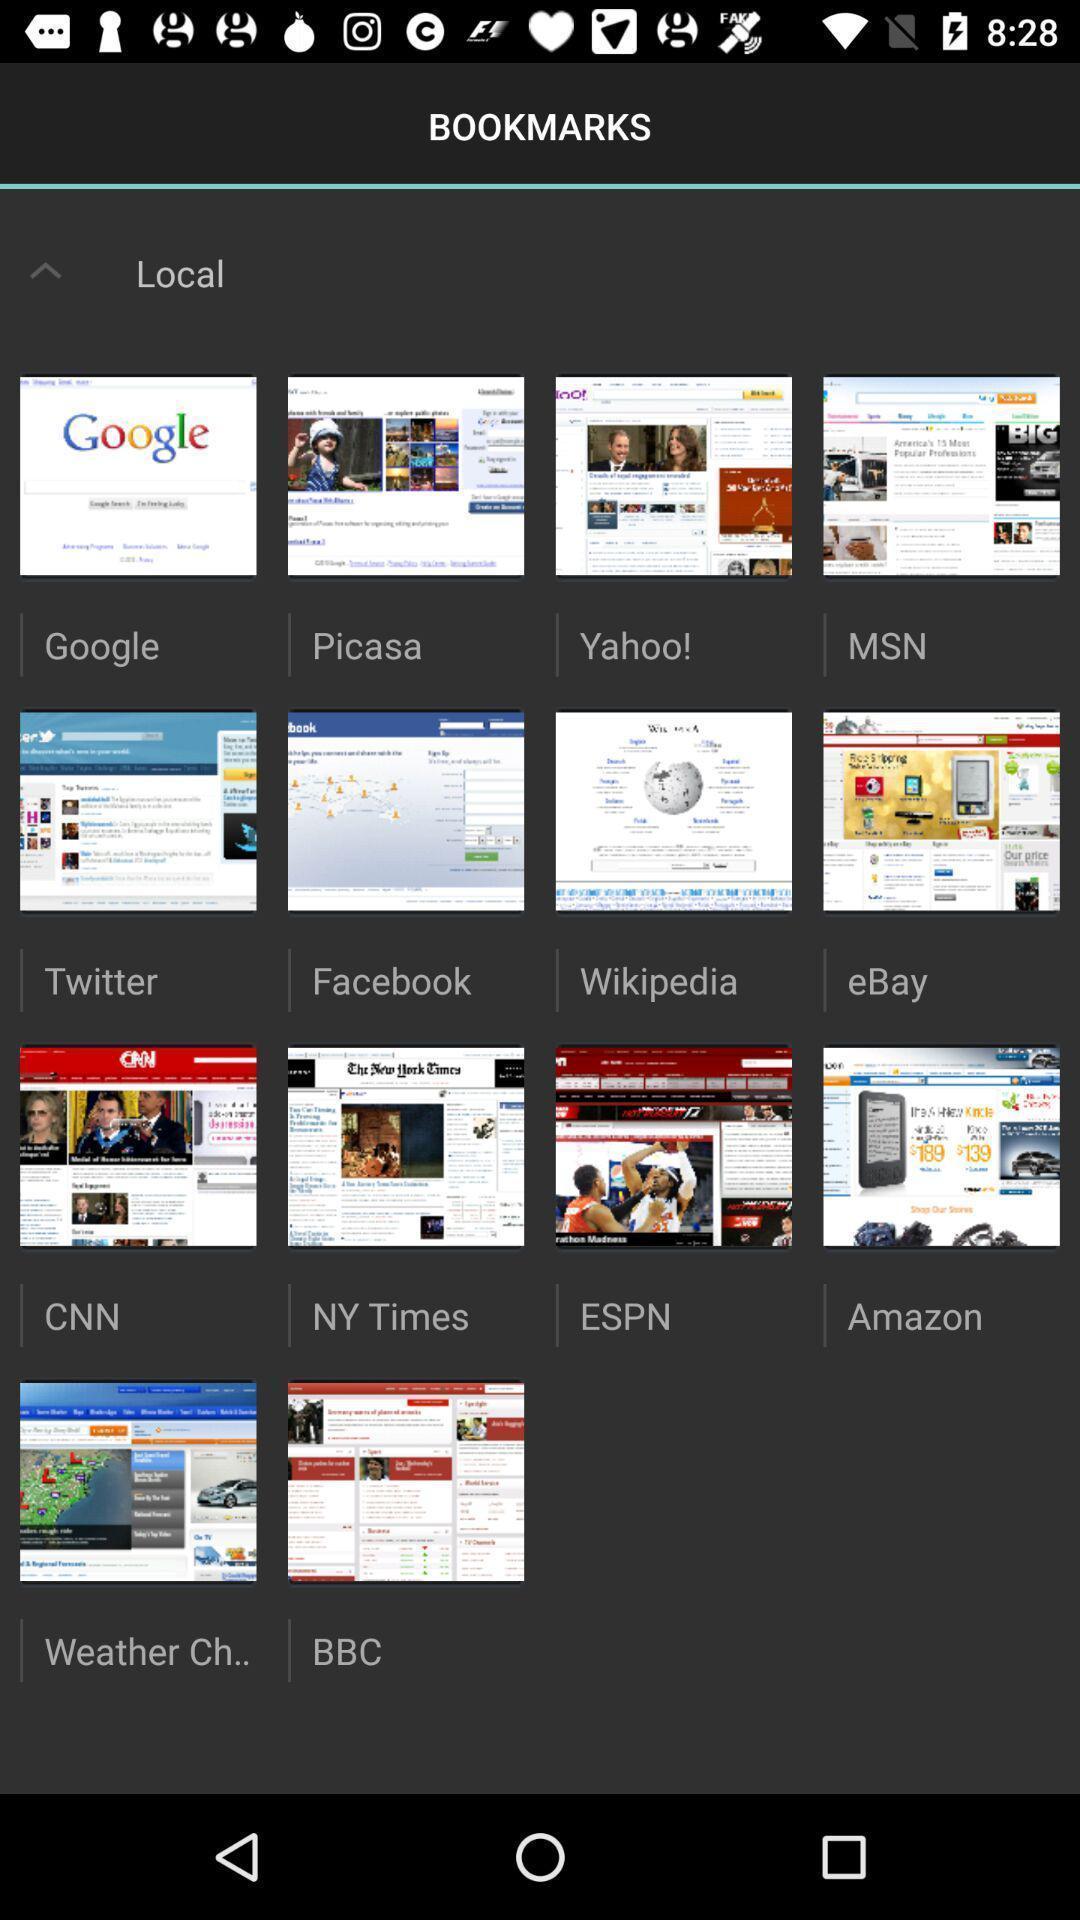What details can you identify in this image? Screen displaying multiple different pages. 